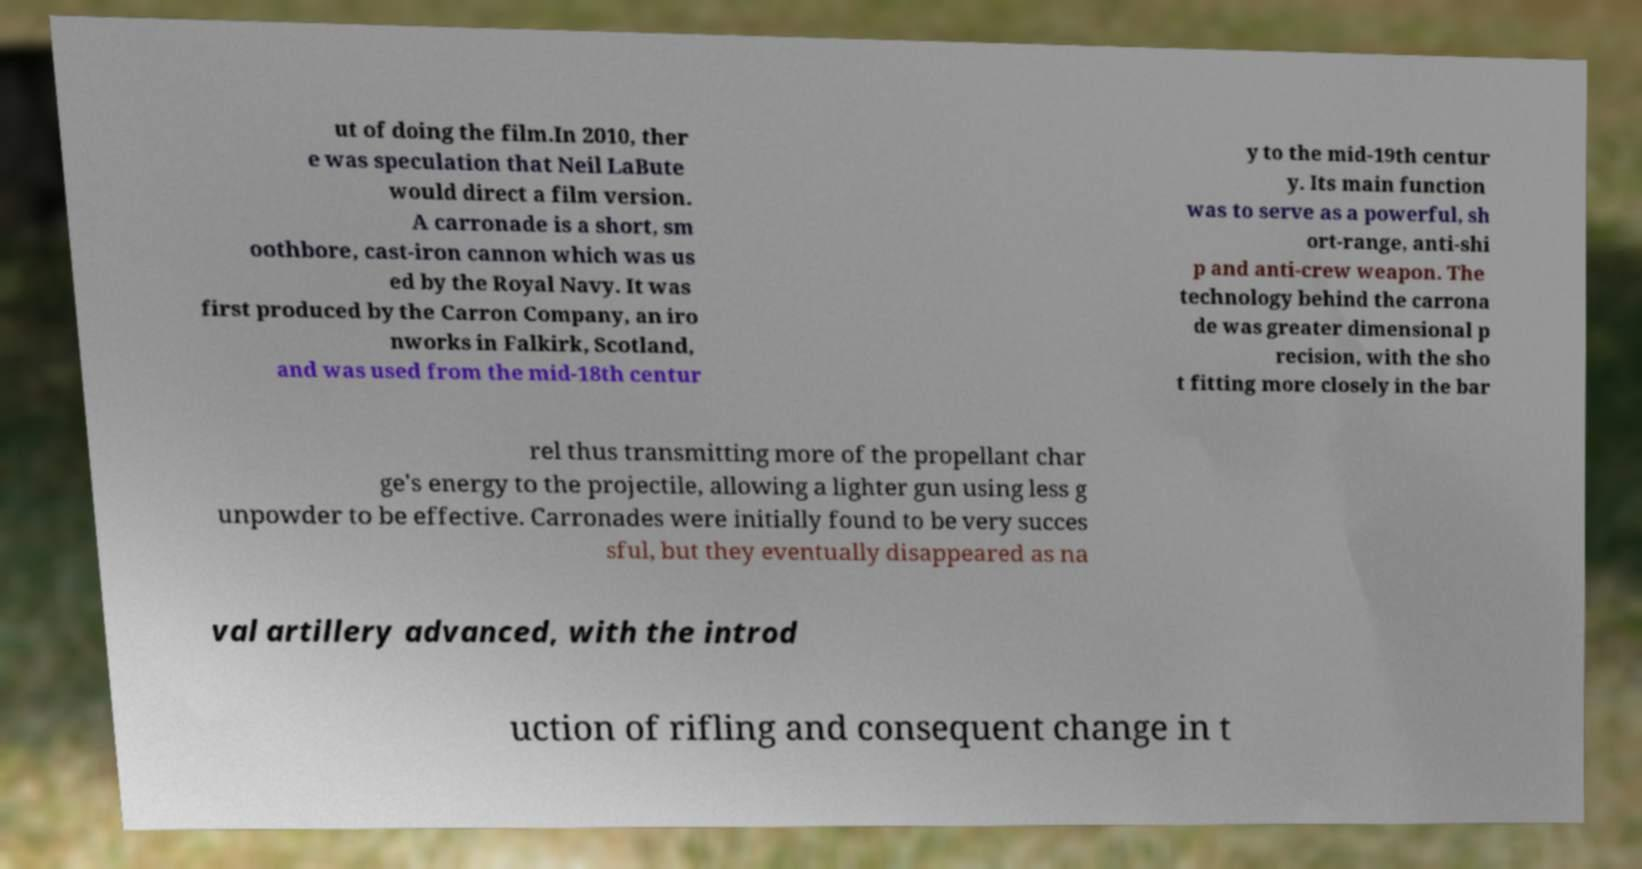What messages or text are displayed in this image? I need them in a readable, typed format. ut of doing the film.In 2010, ther e was speculation that Neil LaBute would direct a film version. A carronade is a short, sm oothbore, cast-iron cannon which was us ed by the Royal Navy. It was first produced by the Carron Company, an iro nworks in Falkirk, Scotland, and was used from the mid-18th centur y to the mid-19th centur y. Its main function was to serve as a powerful, sh ort-range, anti-shi p and anti-crew weapon. The technology behind the carrona de was greater dimensional p recision, with the sho t fitting more closely in the bar rel thus transmitting more of the propellant char ge's energy to the projectile, allowing a lighter gun using less g unpowder to be effective. Carronades were initially found to be very succes sful, but they eventually disappeared as na val artillery advanced, with the introd uction of rifling and consequent change in t 